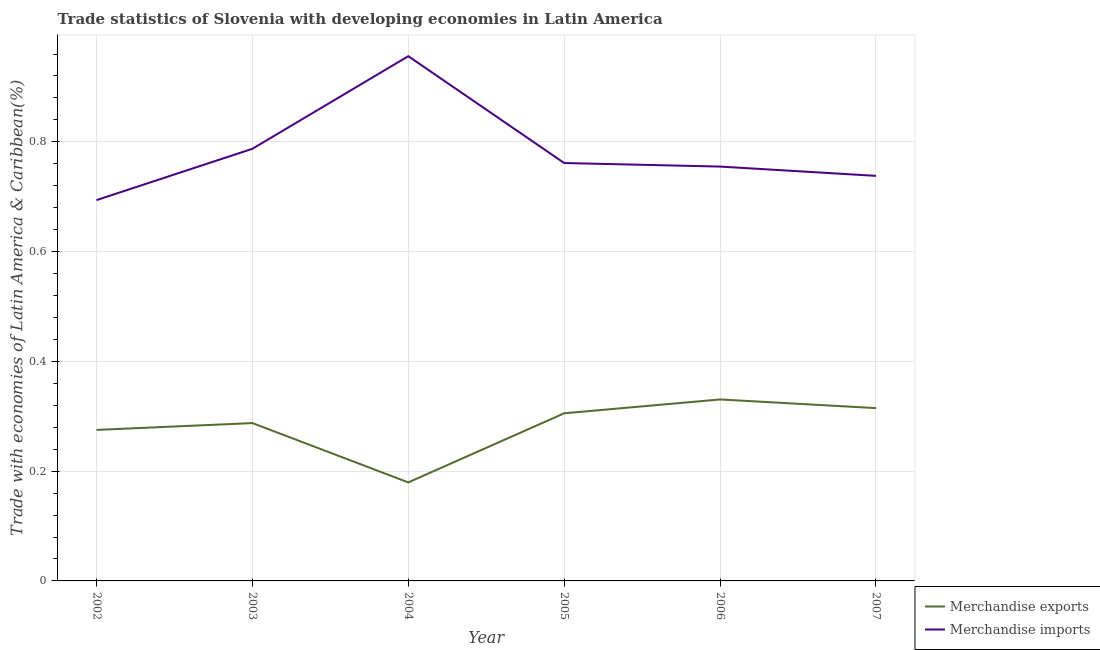How many different coloured lines are there?
Keep it short and to the point. 2. What is the merchandise imports in 2004?
Your answer should be compact. 0.96. Across all years, what is the maximum merchandise imports?
Offer a terse response. 0.96. Across all years, what is the minimum merchandise exports?
Give a very brief answer. 0.18. In which year was the merchandise exports minimum?
Provide a short and direct response. 2004. What is the total merchandise exports in the graph?
Provide a succinct answer. 1.69. What is the difference between the merchandise imports in 2004 and that in 2006?
Provide a short and direct response. 0.2. What is the difference between the merchandise exports in 2004 and the merchandise imports in 2002?
Provide a succinct answer. -0.51. What is the average merchandise exports per year?
Keep it short and to the point. 0.28. In the year 2005, what is the difference between the merchandise imports and merchandise exports?
Provide a succinct answer. 0.46. What is the ratio of the merchandise imports in 2005 to that in 2006?
Your answer should be compact. 1.01. Is the merchandise exports in 2002 less than that in 2003?
Keep it short and to the point. Yes. Is the difference between the merchandise exports in 2005 and 2007 greater than the difference between the merchandise imports in 2005 and 2007?
Give a very brief answer. No. What is the difference between the highest and the second highest merchandise imports?
Your answer should be compact. 0.17. What is the difference between the highest and the lowest merchandise exports?
Offer a terse response. 0.15. Is the sum of the merchandise exports in 2002 and 2005 greater than the maximum merchandise imports across all years?
Make the answer very short. No. Does the merchandise imports monotonically increase over the years?
Provide a short and direct response. No. Is the merchandise exports strictly less than the merchandise imports over the years?
Your answer should be very brief. Yes. What is the difference between two consecutive major ticks on the Y-axis?
Your response must be concise. 0.2. What is the title of the graph?
Ensure brevity in your answer.  Trade statistics of Slovenia with developing economies in Latin America. Does "Age 15+" appear as one of the legend labels in the graph?
Make the answer very short. No. What is the label or title of the X-axis?
Ensure brevity in your answer.  Year. What is the label or title of the Y-axis?
Make the answer very short. Trade with economies of Latin America & Caribbean(%). What is the Trade with economies of Latin America & Caribbean(%) of Merchandise exports in 2002?
Offer a terse response. 0.28. What is the Trade with economies of Latin America & Caribbean(%) of Merchandise imports in 2002?
Make the answer very short. 0.69. What is the Trade with economies of Latin America & Caribbean(%) in Merchandise exports in 2003?
Your answer should be compact. 0.29. What is the Trade with economies of Latin America & Caribbean(%) in Merchandise imports in 2003?
Provide a succinct answer. 0.79. What is the Trade with economies of Latin America & Caribbean(%) in Merchandise exports in 2004?
Provide a short and direct response. 0.18. What is the Trade with economies of Latin America & Caribbean(%) in Merchandise imports in 2004?
Your answer should be very brief. 0.96. What is the Trade with economies of Latin America & Caribbean(%) of Merchandise exports in 2005?
Offer a terse response. 0.31. What is the Trade with economies of Latin America & Caribbean(%) in Merchandise imports in 2005?
Give a very brief answer. 0.76. What is the Trade with economies of Latin America & Caribbean(%) of Merchandise exports in 2006?
Keep it short and to the point. 0.33. What is the Trade with economies of Latin America & Caribbean(%) in Merchandise imports in 2006?
Keep it short and to the point. 0.75. What is the Trade with economies of Latin America & Caribbean(%) of Merchandise exports in 2007?
Give a very brief answer. 0.31. What is the Trade with economies of Latin America & Caribbean(%) in Merchandise imports in 2007?
Provide a short and direct response. 0.74. Across all years, what is the maximum Trade with economies of Latin America & Caribbean(%) in Merchandise exports?
Your answer should be compact. 0.33. Across all years, what is the maximum Trade with economies of Latin America & Caribbean(%) of Merchandise imports?
Your answer should be compact. 0.96. Across all years, what is the minimum Trade with economies of Latin America & Caribbean(%) of Merchandise exports?
Your answer should be very brief. 0.18. Across all years, what is the minimum Trade with economies of Latin America & Caribbean(%) of Merchandise imports?
Offer a very short reply. 0.69. What is the total Trade with economies of Latin America & Caribbean(%) in Merchandise exports in the graph?
Your answer should be very brief. 1.69. What is the total Trade with economies of Latin America & Caribbean(%) of Merchandise imports in the graph?
Your answer should be very brief. 4.69. What is the difference between the Trade with economies of Latin America & Caribbean(%) in Merchandise exports in 2002 and that in 2003?
Your answer should be compact. -0.01. What is the difference between the Trade with economies of Latin America & Caribbean(%) in Merchandise imports in 2002 and that in 2003?
Your answer should be compact. -0.09. What is the difference between the Trade with economies of Latin America & Caribbean(%) in Merchandise exports in 2002 and that in 2004?
Your answer should be compact. 0.1. What is the difference between the Trade with economies of Latin America & Caribbean(%) in Merchandise imports in 2002 and that in 2004?
Provide a succinct answer. -0.26. What is the difference between the Trade with economies of Latin America & Caribbean(%) of Merchandise exports in 2002 and that in 2005?
Give a very brief answer. -0.03. What is the difference between the Trade with economies of Latin America & Caribbean(%) of Merchandise imports in 2002 and that in 2005?
Offer a very short reply. -0.07. What is the difference between the Trade with economies of Latin America & Caribbean(%) in Merchandise exports in 2002 and that in 2006?
Offer a very short reply. -0.06. What is the difference between the Trade with economies of Latin America & Caribbean(%) of Merchandise imports in 2002 and that in 2006?
Provide a succinct answer. -0.06. What is the difference between the Trade with economies of Latin America & Caribbean(%) in Merchandise exports in 2002 and that in 2007?
Your response must be concise. -0.04. What is the difference between the Trade with economies of Latin America & Caribbean(%) of Merchandise imports in 2002 and that in 2007?
Your answer should be very brief. -0.04. What is the difference between the Trade with economies of Latin America & Caribbean(%) in Merchandise exports in 2003 and that in 2004?
Ensure brevity in your answer.  0.11. What is the difference between the Trade with economies of Latin America & Caribbean(%) of Merchandise imports in 2003 and that in 2004?
Your response must be concise. -0.17. What is the difference between the Trade with economies of Latin America & Caribbean(%) in Merchandise exports in 2003 and that in 2005?
Ensure brevity in your answer.  -0.02. What is the difference between the Trade with economies of Latin America & Caribbean(%) of Merchandise imports in 2003 and that in 2005?
Give a very brief answer. 0.03. What is the difference between the Trade with economies of Latin America & Caribbean(%) in Merchandise exports in 2003 and that in 2006?
Give a very brief answer. -0.04. What is the difference between the Trade with economies of Latin America & Caribbean(%) in Merchandise imports in 2003 and that in 2006?
Make the answer very short. 0.03. What is the difference between the Trade with economies of Latin America & Caribbean(%) in Merchandise exports in 2003 and that in 2007?
Provide a short and direct response. -0.03. What is the difference between the Trade with economies of Latin America & Caribbean(%) of Merchandise imports in 2003 and that in 2007?
Make the answer very short. 0.05. What is the difference between the Trade with economies of Latin America & Caribbean(%) of Merchandise exports in 2004 and that in 2005?
Your response must be concise. -0.13. What is the difference between the Trade with economies of Latin America & Caribbean(%) in Merchandise imports in 2004 and that in 2005?
Your response must be concise. 0.19. What is the difference between the Trade with economies of Latin America & Caribbean(%) in Merchandise exports in 2004 and that in 2006?
Your answer should be compact. -0.15. What is the difference between the Trade with economies of Latin America & Caribbean(%) in Merchandise imports in 2004 and that in 2006?
Your response must be concise. 0.2. What is the difference between the Trade with economies of Latin America & Caribbean(%) in Merchandise exports in 2004 and that in 2007?
Offer a terse response. -0.14. What is the difference between the Trade with economies of Latin America & Caribbean(%) in Merchandise imports in 2004 and that in 2007?
Keep it short and to the point. 0.22. What is the difference between the Trade with economies of Latin America & Caribbean(%) of Merchandise exports in 2005 and that in 2006?
Offer a terse response. -0.03. What is the difference between the Trade with economies of Latin America & Caribbean(%) in Merchandise imports in 2005 and that in 2006?
Give a very brief answer. 0.01. What is the difference between the Trade with economies of Latin America & Caribbean(%) of Merchandise exports in 2005 and that in 2007?
Provide a succinct answer. -0.01. What is the difference between the Trade with economies of Latin America & Caribbean(%) of Merchandise imports in 2005 and that in 2007?
Your answer should be very brief. 0.02. What is the difference between the Trade with economies of Latin America & Caribbean(%) in Merchandise exports in 2006 and that in 2007?
Your answer should be compact. 0.02. What is the difference between the Trade with economies of Latin America & Caribbean(%) of Merchandise imports in 2006 and that in 2007?
Provide a succinct answer. 0.02. What is the difference between the Trade with economies of Latin America & Caribbean(%) of Merchandise exports in 2002 and the Trade with economies of Latin America & Caribbean(%) of Merchandise imports in 2003?
Offer a very short reply. -0.51. What is the difference between the Trade with economies of Latin America & Caribbean(%) in Merchandise exports in 2002 and the Trade with economies of Latin America & Caribbean(%) in Merchandise imports in 2004?
Give a very brief answer. -0.68. What is the difference between the Trade with economies of Latin America & Caribbean(%) of Merchandise exports in 2002 and the Trade with economies of Latin America & Caribbean(%) of Merchandise imports in 2005?
Your answer should be very brief. -0.49. What is the difference between the Trade with economies of Latin America & Caribbean(%) in Merchandise exports in 2002 and the Trade with economies of Latin America & Caribbean(%) in Merchandise imports in 2006?
Offer a terse response. -0.48. What is the difference between the Trade with economies of Latin America & Caribbean(%) of Merchandise exports in 2002 and the Trade with economies of Latin America & Caribbean(%) of Merchandise imports in 2007?
Give a very brief answer. -0.46. What is the difference between the Trade with economies of Latin America & Caribbean(%) of Merchandise exports in 2003 and the Trade with economies of Latin America & Caribbean(%) of Merchandise imports in 2004?
Make the answer very short. -0.67. What is the difference between the Trade with economies of Latin America & Caribbean(%) in Merchandise exports in 2003 and the Trade with economies of Latin America & Caribbean(%) in Merchandise imports in 2005?
Offer a very short reply. -0.47. What is the difference between the Trade with economies of Latin America & Caribbean(%) in Merchandise exports in 2003 and the Trade with economies of Latin America & Caribbean(%) in Merchandise imports in 2006?
Provide a succinct answer. -0.47. What is the difference between the Trade with economies of Latin America & Caribbean(%) in Merchandise exports in 2003 and the Trade with economies of Latin America & Caribbean(%) in Merchandise imports in 2007?
Provide a short and direct response. -0.45. What is the difference between the Trade with economies of Latin America & Caribbean(%) in Merchandise exports in 2004 and the Trade with economies of Latin America & Caribbean(%) in Merchandise imports in 2005?
Provide a short and direct response. -0.58. What is the difference between the Trade with economies of Latin America & Caribbean(%) in Merchandise exports in 2004 and the Trade with economies of Latin America & Caribbean(%) in Merchandise imports in 2006?
Ensure brevity in your answer.  -0.58. What is the difference between the Trade with economies of Latin America & Caribbean(%) in Merchandise exports in 2004 and the Trade with economies of Latin America & Caribbean(%) in Merchandise imports in 2007?
Ensure brevity in your answer.  -0.56. What is the difference between the Trade with economies of Latin America & Caribbean(%) of Merchandise exports in 2005 and the Trade with economies of Latin America & Caribbean(%) of Merchandise imports in 2006?
Your response must be concise. -0.45. What is the difference between the Trade with economies of Latin America & Caribbean(%) in Merchandise exports in 2005 and the Trade with economies of Latin America & Caribbean(%) in Merchandise imports in 2007?
Ensure brevity in your answer.  -0.43. What is the difference between the Trade with economies of Latin America & Caribbean(%) of Merchandise exports in 2006 and the Trade with economies of Latin America & Caribbean(%) of Merchandise imports in 2007?
Keep it short and to the point. -0.41. What is the average Trade with economies of Latin America & Caribbean(%) of Merchandise exports per year?
Offer a very short reply. 0.28. What is the average Trade with economies of Latin America & Caribbean(%) of Merchandise imports per year?
Ensure brevity in your answer.  0.78. In the year 2002, what is the difference between the Trade with economies of Latin America & Caribbean(%) in Merchandise exports and Trade with economies of Latin America & Caribbean(%) in Merchandise imports?
Your answer should be very brief. -0.42. In the year 2003, what is the difference between the Trade with economies of Latin America & Caribbean(%) of Merchandise exports and Trade with economies of Latin America & Caribbean(%) of Merchandise imports?
Provide a succinct answer. -0.5. In the year 2004, what is the difference between the Trade with economies of Latin America & Caribbean(%) in Merchandise exports and Trade with economies of Latin America & Caribbean(%) in Merchandise imports?
Your answer should be very brief. -0.78. In the year 2005, what is the difference between the Trade with economies of Latin America & Caribbean(%) in Merchandise exports and Trade with economies of Latin America & Caribbean(%) in Merchandise imports?
Give a very brief answer. -0.46. In the year 2006, what is the difference between the Trade with economies of Latin America & Caribbean(%) in Merchandise exports and Trade with economies of Latin America & Caribbean(%) in Merchandise imports?
Your answer should be compact. -0.42. In the year 2007, what is the difference between the Trade with economies of Latin America & Caribbean(%) of Merchandise exports and Trade with economies of Latin America & Caribbean(%) of Merchandise imports?
Keep it short and to the point. -0.42. What is the ratio of the Trade with economies of Latin America & Caribbean(%) in Merchandise exports in 2002 to that in 2003?
Provide a succinct answer. 0.96. What is the ratio of the Trade with economies of Latin America & Caribbean(%) of Merchandise imports in 2002 to that in 2003?
Make the answer very short. 0.88. What is the ratio of the Trade with economies of Latin America & Caribbean(%) of Merchandise exports in 2002 to that in 2004?
Your answer should be very brief. 1.53. What is the ratio of the Trade with economies of Latin America & Caribbean(%) in Merchandise imports in 2002 to that in 2004?
Provide a succinct answer. 0.73. What is the ratio of the Trade with economies of Latin America & Caribbean(%) of Merchandise exports in 2002 to that in 2005?
Your answer should be very brief. 0.9. What is the ratio of the Trade with economies of Latin America & Caribbean(%) in Merchandise imports in 2002 to that in 2005?
Keep it short and to the point. 0.91. What is the ratio of the Trade with economies of Latin America & Caribbean(%) of Merchandise exports in 2002 to that in 2006?
Ensure brevity in your answer.  0.83. What is the ratio of the Trade with economies of Latin America & Caribbean(%) in Merchandise imports in 2002 to that in 2006?
Your answer should be compact. 0.92. What is the ratio of the Trade with economies of Latin America & Caribbean(%) in Merchandise exports in 2002 to that in 2007?
Your answer should be compact. 0.87. What is the ratio of the Trade with economies of Latin America & Caribbean(%) of Merchandise imports in 2002 to that in 2007?
Your answer should be very brief. 0.94. What is the ratio of the Trade with economies of Latin America & Caribbean(%) in Merchandise exports in 2003 to that in 2004?
Your response must be concise. 1.6. What is the ratio of the Trade with economies of Latin America & Caribbean(%) of Merchandise imports in 2003 to that in 2004?
Give a very brief answer. 0.82. What is the ratio of the Trade with economies of Latin America & Caribbean(%) of Merchandise exports in 2003 to that in 2005?
Keep it short and to the point. 0.94. What is the ratio of the Trade with economies of Latin America & Caribbean(%) of Merchandise imports in 2003 to that in 2005?
Provide a short and direct response. 1.03. What is the ratio of the Trade with economies of Latin America & Caribbean(%) in Merchandise exports in 2003 to that in 2006?
Ensure brevity in your answer.  0.87. What is the ratio of the Trade with economies of Latin America & Caribbean(%) in Merchandise imports in 2003 to that in 2006?
Make the answer very short. 1.04. What is the ratio of the Trade with economies of Latin America & Caribbean(%) of Merchandise exports in 2003 to that in 2007?
Keep it short and to the point. 0.91. What is the ratio of the Trade with economies of Latin America & Caribbean(%) of Merchandise imports in 2003 to that in 2007?
Keep it short and to the point. 1.07. What is the ratio of the Trade with economies of Latin America & Caribbean(%) of Merchandise exports in 2004 to that in 2005?
Offer a terse response. 0.59. What is the ratio of the Trade with economies of Latin America & Caribbean(%) in Merchandise imports in 2004 to that in 2005?
Keep it short and to the point. 1.26. What is the ratio of the Trade with economies of Latin America & Caribbean(%) in Merchandise exports in 2004 to that in 2006?
Make the answer very short. 0.54. What is the ratio of the Trade with economies of Latin America & Caribbean(%) of Merchandise imports in 2004 to that in 2006?
Offer a very short reply. 1.27. What is the ratio of the Trade with economies of Latin America & Caribbean(%) in Merchandise exports in 2004 to that in 2007?
Your answer should be compact. 0.57. What is the ratio of the Trade with economies of Latin America & Caribbean(%) in Merchandise imports in 2004 to that in 2007?
Provide a short and direct response. 1.3. What is the ratio of the Trade with economies of Latin America & Caribbean(%) of Merchandise exports in 2005 to that in 2006?
Your response must be concise. 0.92. What is the ratio of the Trade with economies of Latin America & Caribbean(%) in Merchandise imports in 2005 to that in 2006?
Offer a terse response. 1.01. What is the ratio of the Trade with economies of Latin America & Caribbean(%) in Merchandise imports in 2005 to that in 2007?
Keep it short and to the point. 1.03. What is the ratio of the Trade with economies of Latin America & Caribbean(%) in Merchandise exports in 2006 to that in 2007?
Your response must be concise. 1.05. What is the ratio of the Trade with economies of Latin America & Caribbean(%) in Merchandise imports in 2006 to that in 2007?
Keep it short and to the point. 1.02. What is the difference between the highest and the second highest Trade with economies of Latin America & Caribbean(%) of Merchandise exports?
Offer a very short reply. 0.02. What is the difference between the highest and the second highest Trade with economies of Latin America & Caribbean(%) of Merchandise imports?
Provide a short and direct response. 0.17. What is the difference between the highest and the lowest Trade with economies of Latin America & Caribbean(%) of Merchandise exports?
Provide a succinct answer. 0.15. What is the difference between the highest and the lowest Trade with economies of Latin America & Caribbean(%) of Merchandise imports?
Provide a short and direct response. 0.26. 